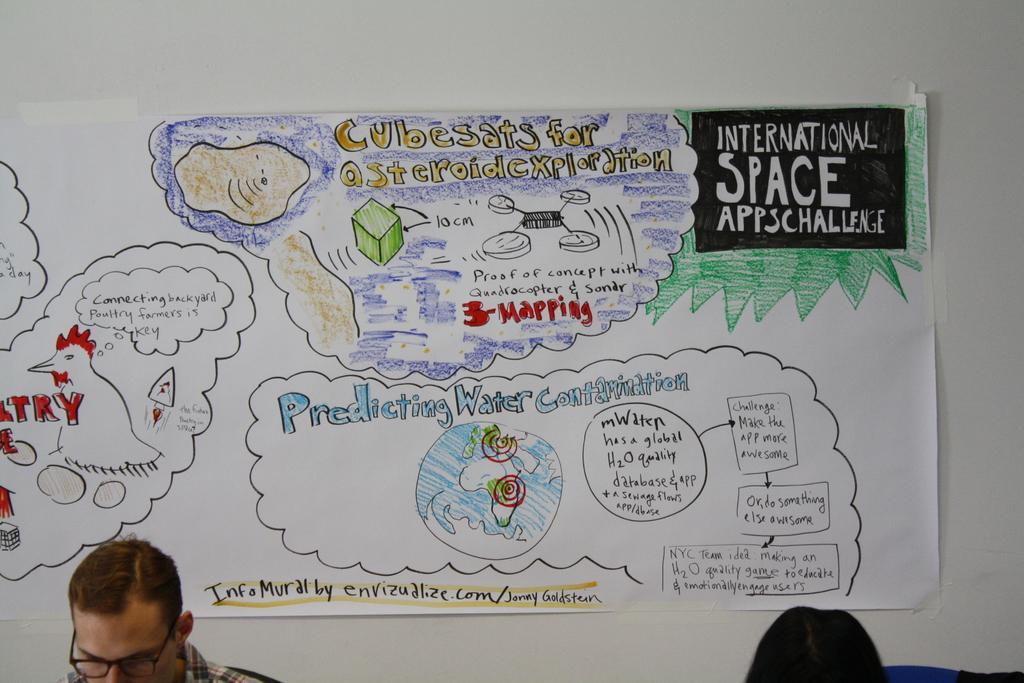Describe this image in one or two sentences. In this image we can see a matter written on the paper, here is the drawing on it, here a man is standing. 